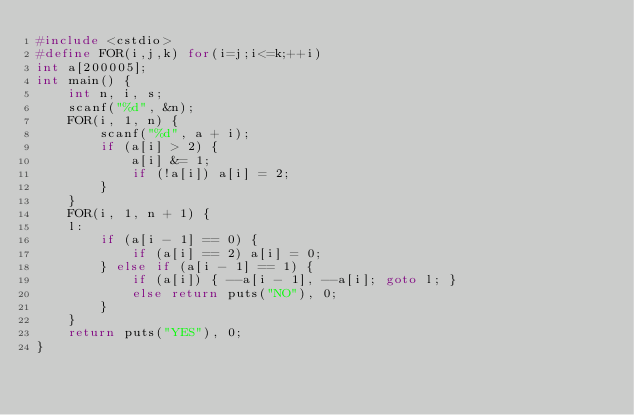Convert code to text. <code><loc_0><loc_0><loc_500><loc_500><_C++_>#include <cstdio>
#define FOR(i,j,k) for(i=j;i<=k;++i)
int a[200005];
int main() {
    int n, i, s;
    scanf("%d", &n);
    FOR(i, 1, n) {
        scanf("%d", a + i);
        if (a[i] > 2) {
            a[i] &= 1;
            if (!a[i]) a[i] = 2;
        }
    }
    FOR(i, 1, n + 1) {
    l:
        if (a[i - 1] == 0) {
            if (a[i] == 2) a[i] = 0;
        } else if (a[i - 1] == 1) {
            if (a[i]) { --a[i - 1], --a[i]; goto l; }
            else return puts("NO"), 0;
        }
    }
    return puts("YES"), 0;
}</code> 